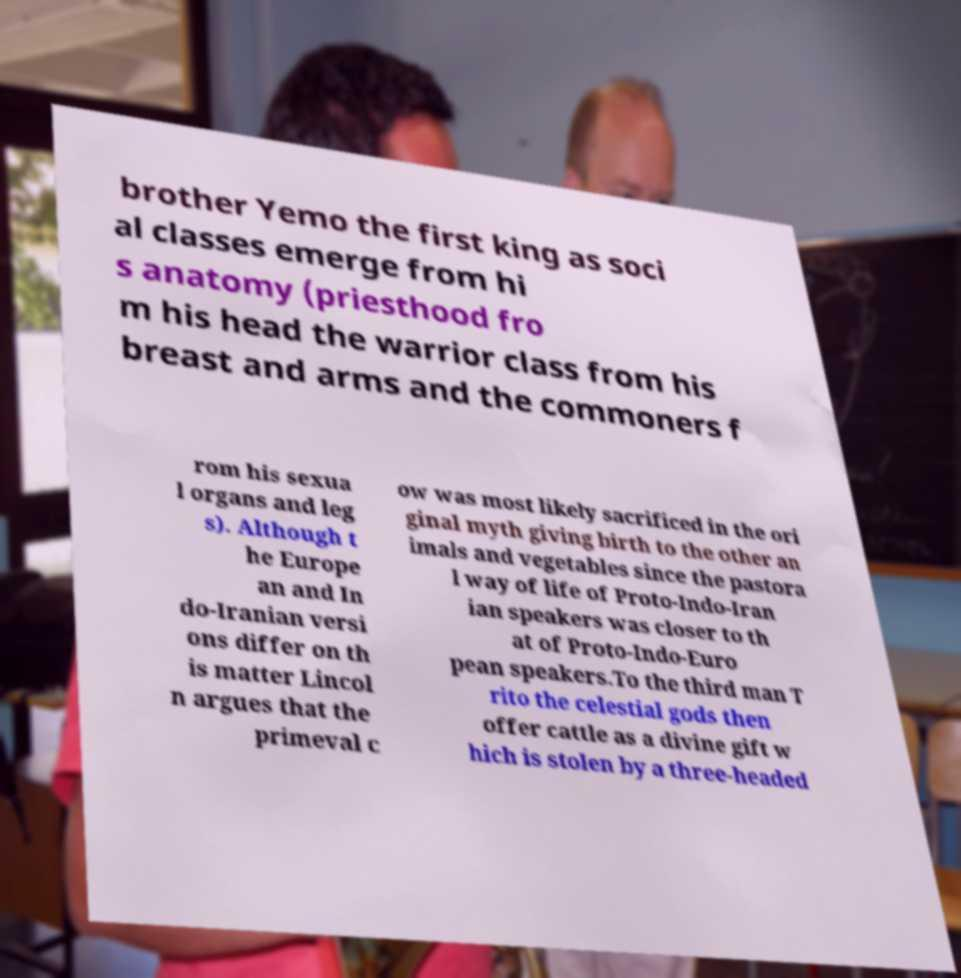Could you assist in decoding the text presented in this image and type it out clearly? brother Yemo the first king as soci al classes emerge from hi s anatomy (priesthood fro m his head the warrior class from his breast and arms and the commoners f rom his sexua l organs and leg s). Although t he Europe an and In do-Iranian versi ons differ on th is matter Lincol n argues that the primeval c ow was most likely sacrificed in the ori ginal myth giving birth to the other an imals and vegetables since the pastora l way of life of Proto-Indo-Iran ian speakers was closer to th at of Proto-Indo-Euro pean speakers.To the third man T rito the celestial gods then offer cattle as a divine gift w hich is stolen by a three-headed 